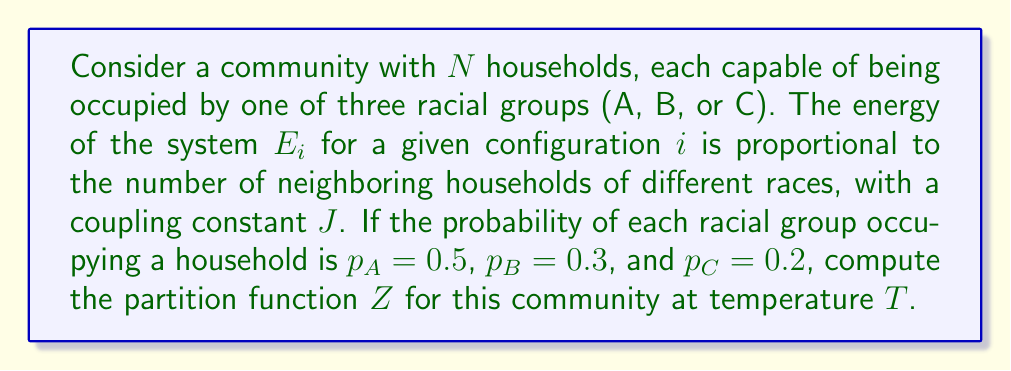Teach me how to tackle this problem. To solve this problem, we'll follow these steps:

1) The partition function $Z$ is given by:

   $$Z = \sum_i e^{-\beta E_i}$$

   where $\beta = \frac{1}{k_B T}$, $k_B$ is Boltzmann's constant, and $T$ is temperature.

2) In this case, we need to sum over all possible configurations of the community. The number of configurations is $3^N$, as each household has 3 possible states.

3) The energy $E_i$ of a configuration depends on the number of neighboring households of different races. Let's denote this number as $n_d$. Then:

   $$E_i = J n_d$$

4) The probability of a specific configuration occurring is the product of the probabilities of each household's state:

   $$P_i = p_A^{N_A} p_B^{N_B} p_C^{N_C}$$

   where $N_A$, $N_B$, and $N_C$ are the numbers of households occupied by each race in that configuration.

5) Combining these, our partition function becomes:

   $$Z = \sum_i P_i e^{-\beta J n_d}$$

6) To simplify, we can group configurations with the same $n_d$:

   $$Z = \sum_{n_d=0}^{N_{max}} g(n_d) \langle P \rangle_{n_d} e^{-\beta J n_d}$$

   where $g(n_d)$ is the number of configurations with $n_d$ different-race neighbors, and $\langle P \rangle_{n_d}$ is the average probability of such configurations.

7) Exact calculation of $g(n_d)$ and $\langle P \rangle_{n_d}$ depends on the specific layout of the community and requires complex combinatorics. In practice, these would often be estimated using Monte Carlo methods.

8) The final form of the partition function is:

   $$Z = \sum_{n_d=0}^{N_{max}} g(n_d) (0.5^{N_A} 0.3^{N_B} 0.2^{N_C})_{avg} e^{-\beta J n_d}$$

   where the subscript 'avg' indicates an average over all configurations with $n_d$ different-race neighbors.
Answer: $$Z = \sum_{n_d=0}^{N_{max}} g(n_d) (0.5^{N_A} 0.3^{N_B} 0.2^{N_C})_{avg} e^{-\beta J n_d}$$ 